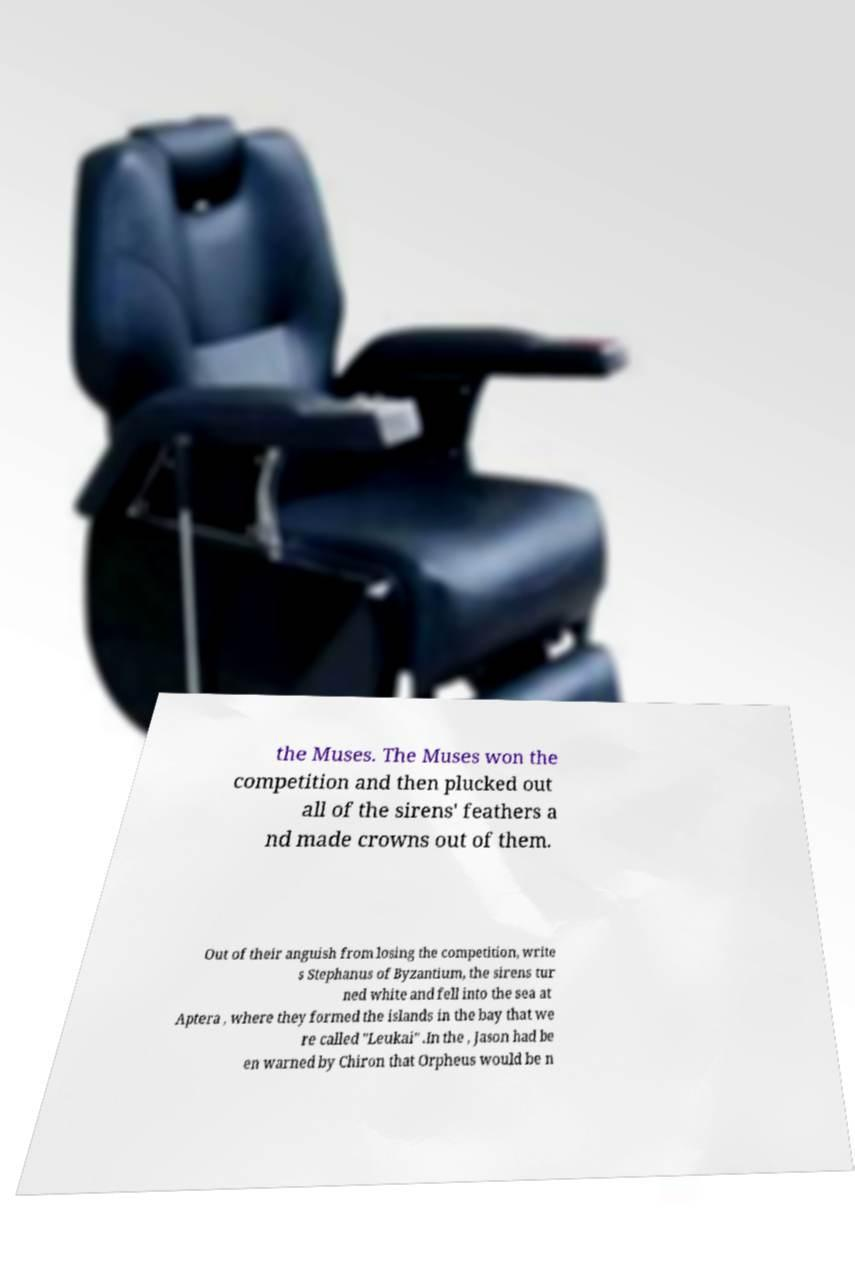Could you extract and type out the text from this image? the Muses. The Muses won the competition and then plucked out all of the sirens' feathers a nd made crowns out of them. Out of their anguish from losing the competition, write s Stephanus of Byzantium, the sirens tur ned white and fell into the sea at Aptera , where they formed the islands in the bay that we re called "Leukai" .In the , Jason had be en warned by Chiron that Orpheus would be n 